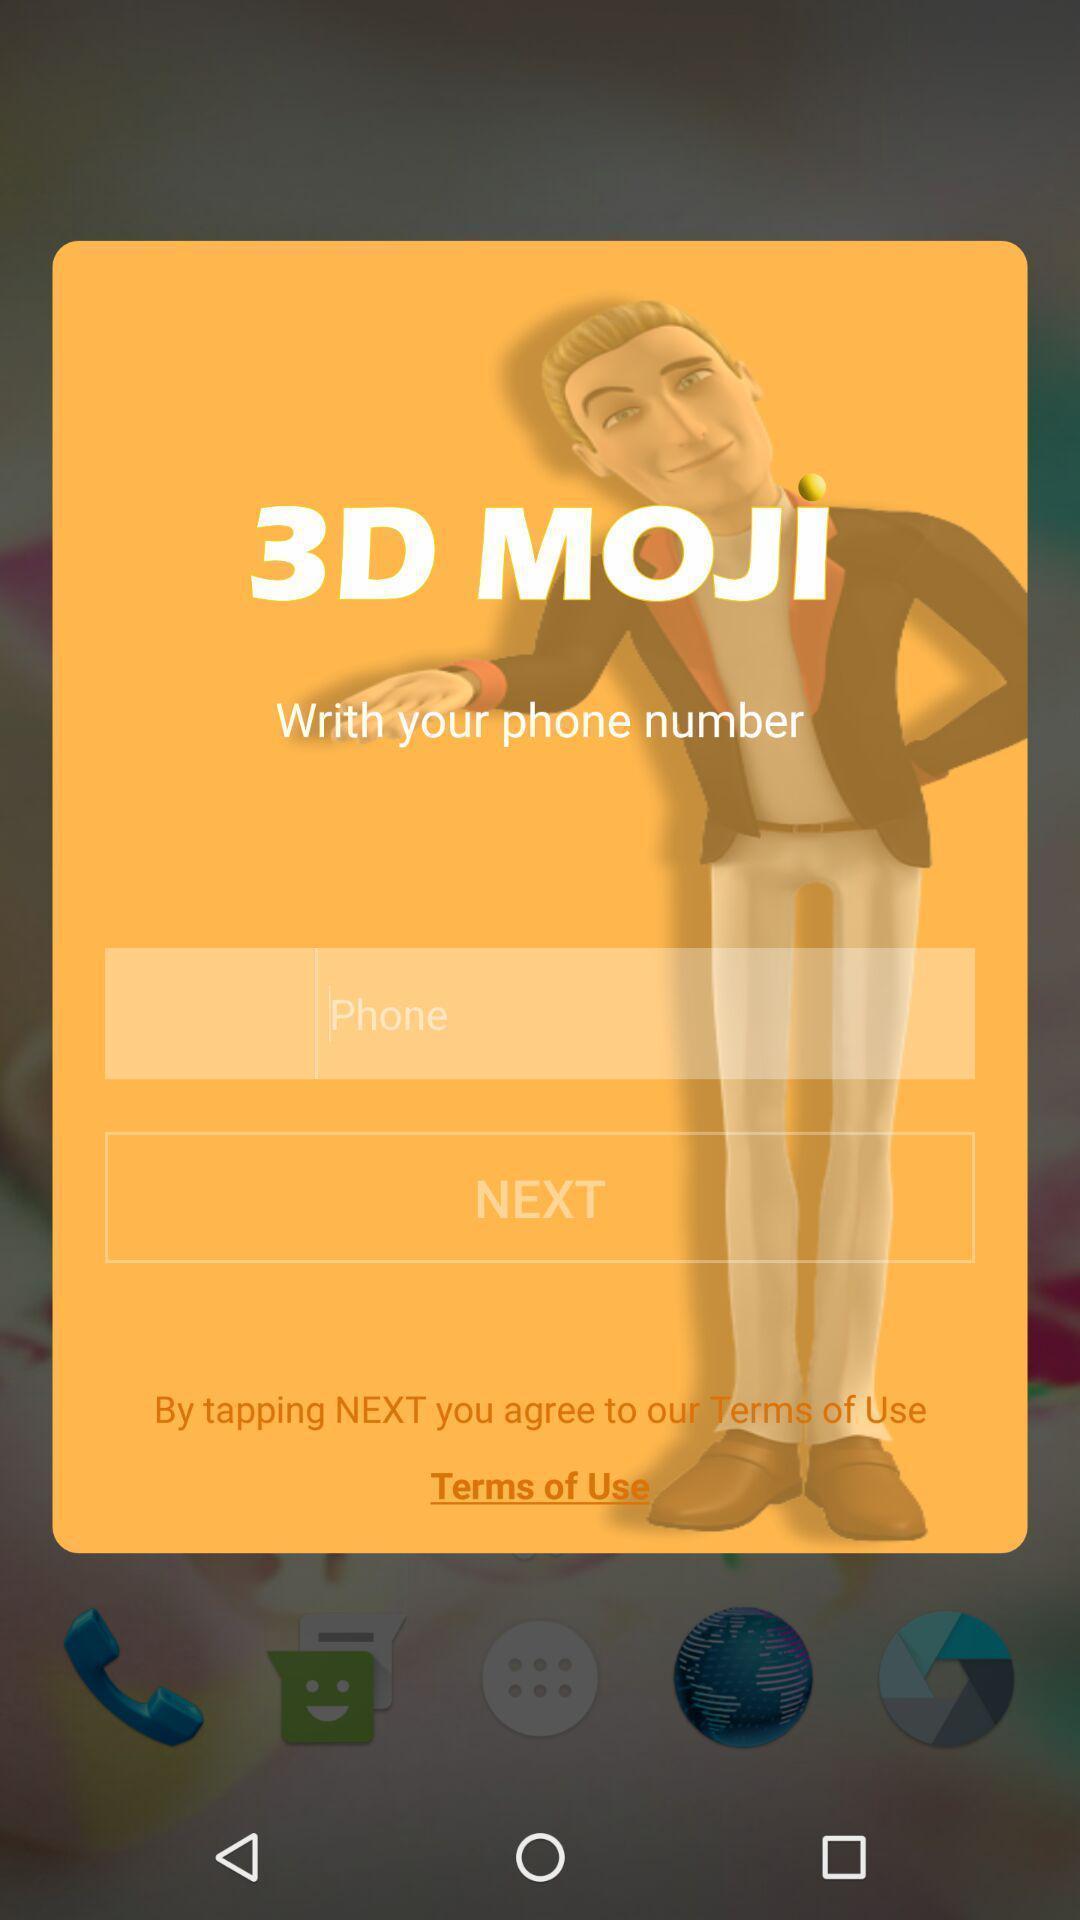Summarize the information in this screenshot. Pop up message showing for emoji app. 